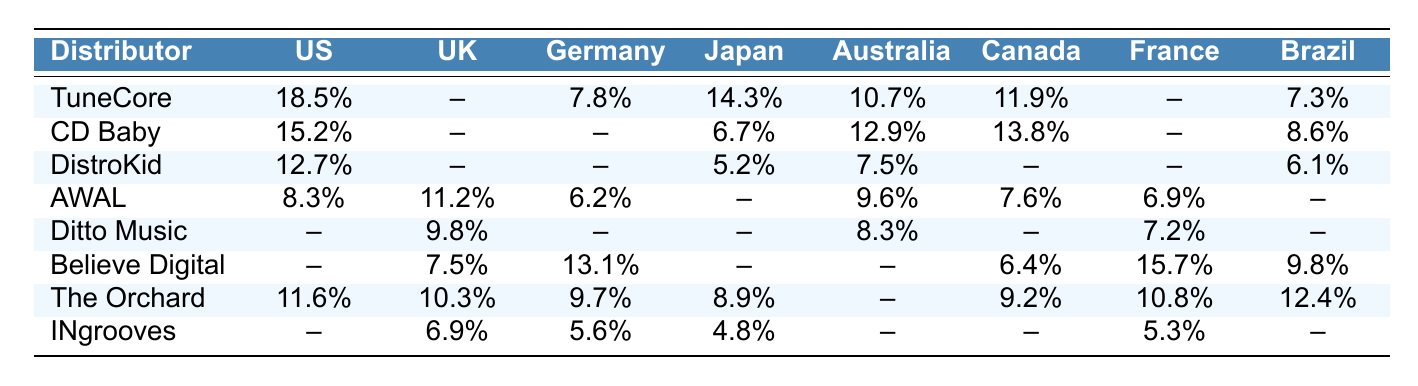What is the market share of TuneCore in the United States? The table shows that TuneCore has a market share of 18.5% in the United States.
Answer: 18.5% Which distributor has the highest market share in France? According to the table, Believe Digital has the highest market share in France at 15.7%.
Answer: Believe Digital What is the total market share of CD Baby across all listed countries? Adding the market shares where CD Baby is listed: (15.2 + 6.7 + 12.9 + 13.8 + 8.6) = 57.2%.
Answer: 57.2% In which country does DistroKid have its highest market share? DistroKid's market shares are 12.7% in the United States, 5.2% in Japan, and 7.5% in Australia. The highest is in the United States at 12.7%.
Answer: United States Does AWAL have a market share in Brazil? According to the table, AWAL does not have any listed market share in Brazil.
Answer: No What is the average market share of The Orchard across all countries where it is listed? The Orchard's market shares are: (11.6 + 10.3 + 9.7 + 8.9 + 9.2 + 10.8 + 12.4) = 72.9% across 7 countries. The average is 72.9 / 7 = 10.4142857%, which rounds to 10.41%.
Answer: 10.41% Which two distributors are present in both Canada and Australia? By reviewing the table, CD Baby and AWAL appear in both Canada and Australia.
Answer: CD Baby and AWAL Is the market share of Believe Digital more than 10% in any country? Believe Digital has a market share greater than 10% in France (15.7%) and Germany (13.1%).
Answer: Yes What is the difference in market share for Ditto Music between the United Kingdom and France? Ditto Music has a market share of 9.8% in the United Kingdom and 7.2% in France. The difference is 9.8 - 7.2 = 2.6%.
Answer: 2.6% Which distributor has the lowest market share in Japan? The table indicates that INgrooves has the lowest market share in Japan at 4.8%.
Answer: INgrooves 